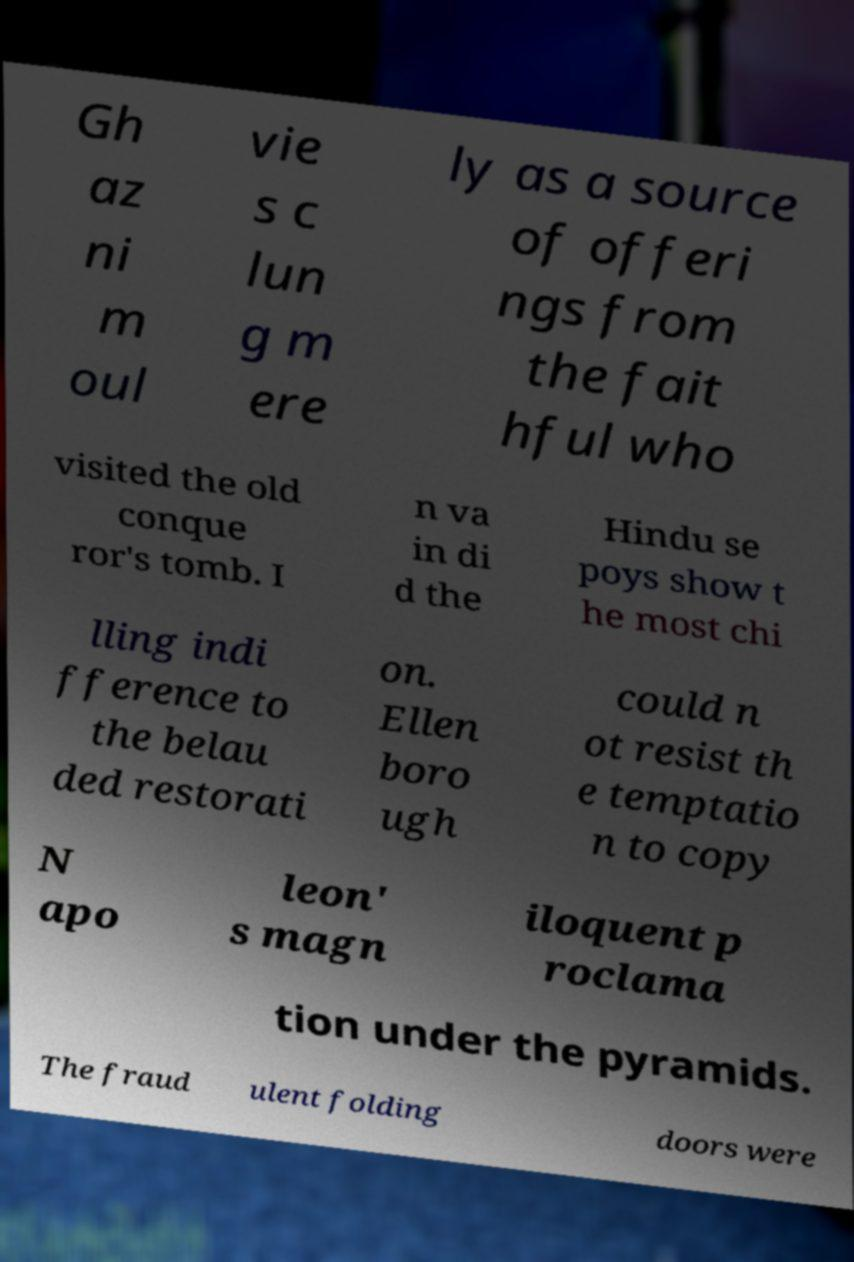Can you accurately transcribe the text from the provided image for me? Gh az ni m oul vie s c lun g m ere ly as a source of offeri ngs from the fait hful who visited the old conque ror's tomb. I n va in di d the Hindu se poys show t he most chi lling indi fference to the belau ded restorati on. Ellen boro ugh could n ot resist th e temptatio n to copy N apo leon' s magn iloquent p roclama tion under the pyramids. The fraud ulent folding doors were 